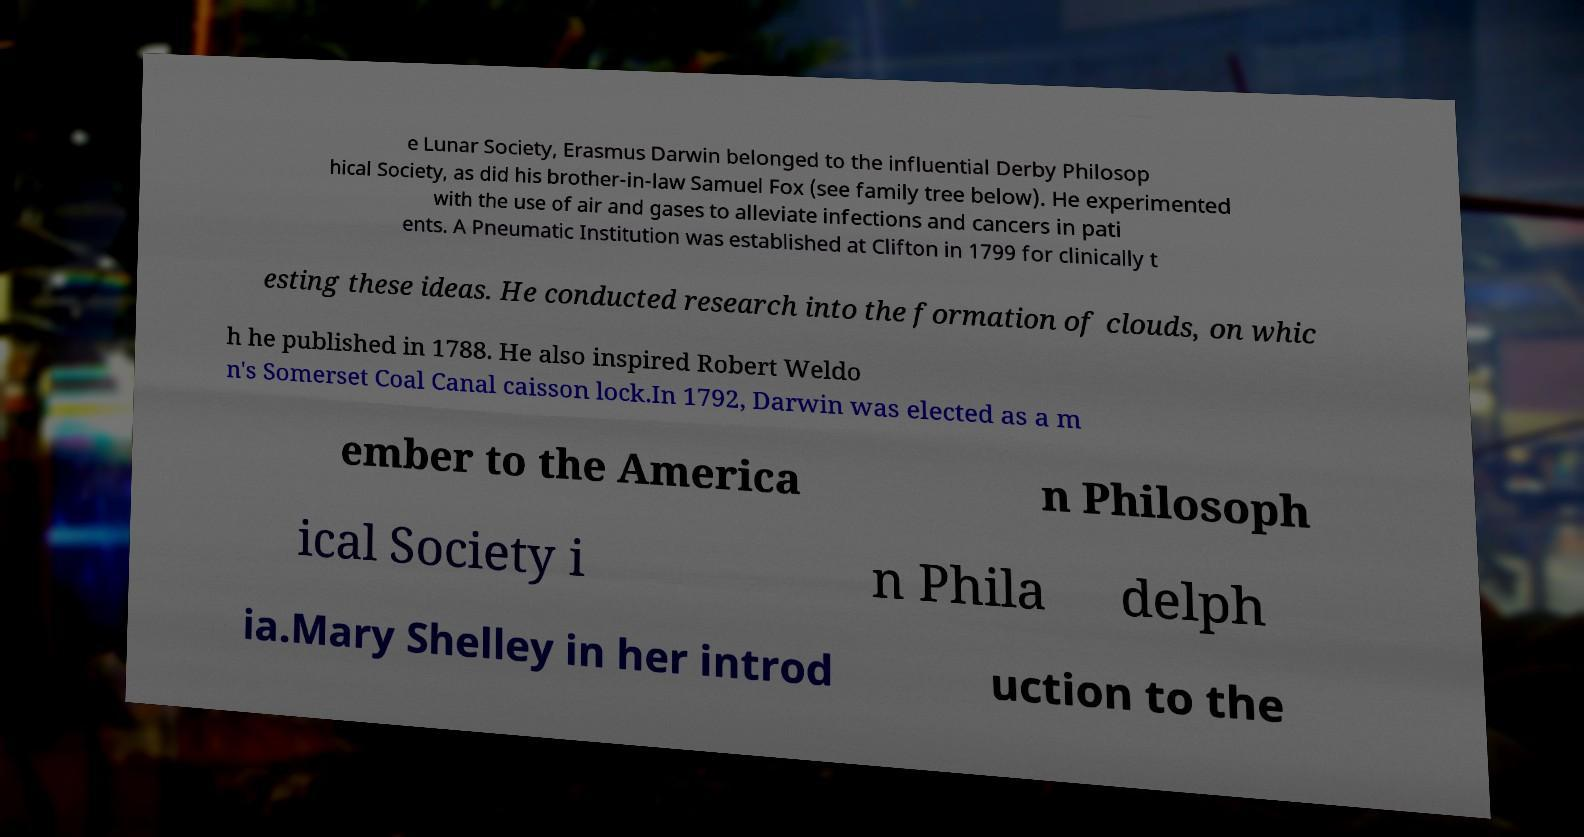Please identify and transcribe the text found in this image. e Lunar Society, Erasmus Darwin belonged to the influential Derby Philosop hical Society, as did his brother-in-law Samuel Fox (see family tree below). He experimented with the use of air and gases to alleviate infections and cancers in pati ents. A Pneumatic Institution was established at Clifton in 1799 for clinically t esting these ideas. He conducted research into the formation of clouds, on whic h he published in 1788. He also inspired Robert Weldo n's Somerset Coal Canal caisson lock.In 1792, Darwin was elected as a m ember to the America n Philosoph ical Society i n Phila delph ia.Mary Shelley in her introd uction to the 